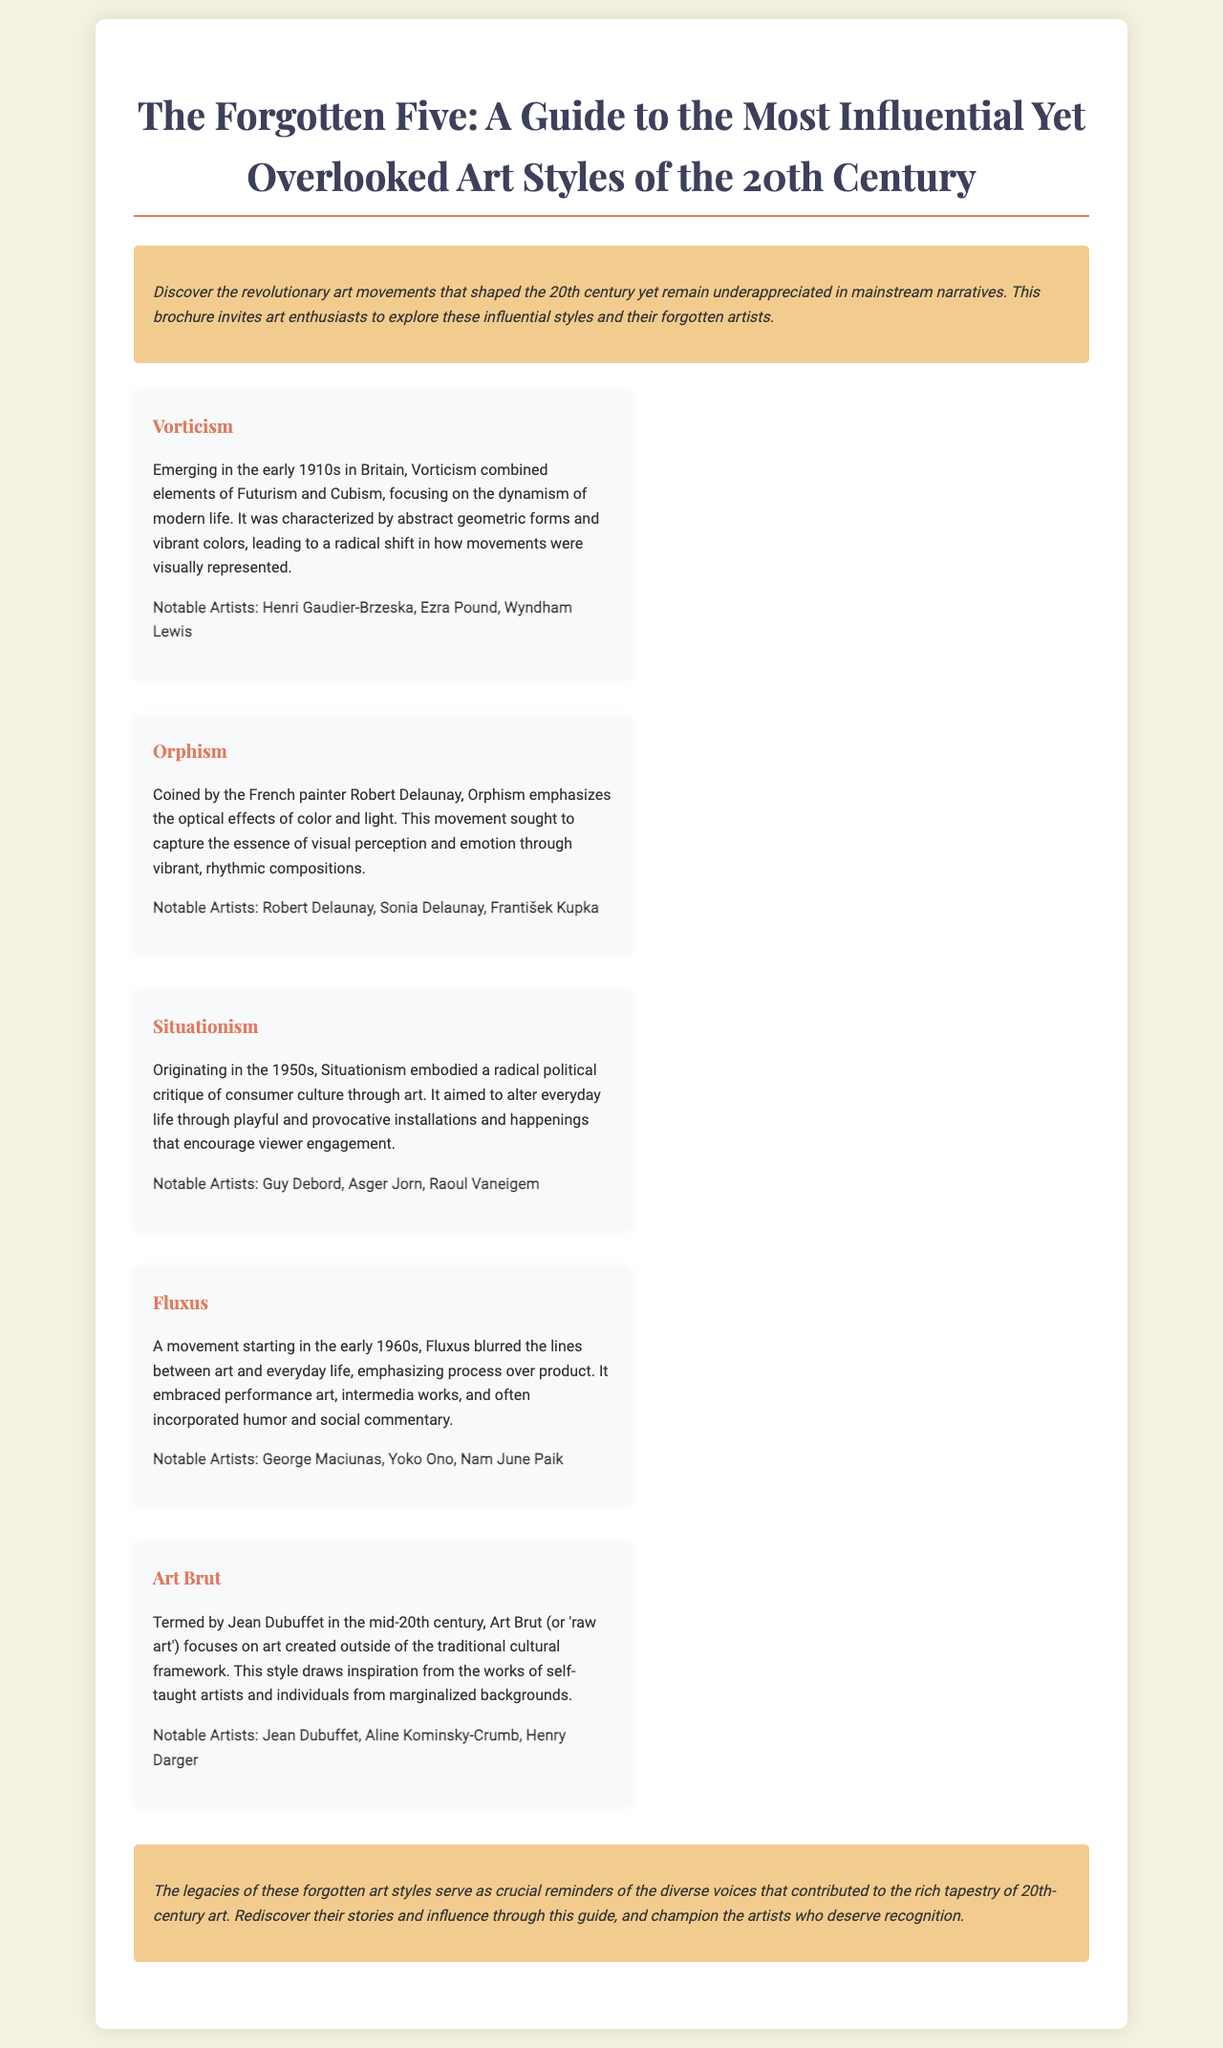What is the title of the brochure? The title is prominently displayed at the top of the document and summarizes the content.
Answer: The Forgotten Five: A Guide to the Most Influential Yet Overlooked Art Styles of the 20th Century When did Vorticism emerge? The document specifies the early timeframe of Vorticism at the beginning of the description.
Answer: Early 1910s Who coined the term Orphism? The document attributes the term to a specific artist, providing clarity on its origin.
Answer: Robert Delaunay What does Situationism critique? The description of Situationism details its focus on a specific cultural aspect.
Answer: Consumer culture What type of art does Art Brut focus on? The document explains that Art Brut centers on art outside a traditional framework.
Answer: Raw art Which notable artist is associated with Fluxus? The document lists notable artists linked with the Fluxus movement.
Answer: Yoko Ono Which two art movements emerged in the 1950s and 1960s? The questions require reasoning to identify movements from the timeline mentioned.
Answer: Situationism and Fluxus What is the primary focus of Vorticism? The document describes the central theme of Vorticism in its introductory sentence.
Answer: Dynamism of modern life What visual elements characterize Orphism? The description of Orphism highlights specific elements related to its style.
Answer: Optical effects of color and light 